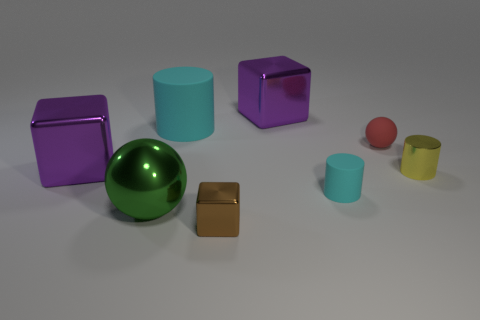There is a thing that is to the right of the large matte object and behind the red matte object; what is its shape?
Provide a short and direct response. Cube. There is a purple shiny thing that is behind the large purple thing that is on the left side of the brown metallic thing; what is its shape?
Give a very brief answer. Cube. Is the shape of the yellow thing the same as the big cyan thing?
Make the answer very short. Yes. What is the material of the small cylinder that is the same color as the large cylinder?
Your answer should be compact. Rubber. Is the large cylinder the same color as the small rubber cylinder?
Offer a very short reply. Yes. What number of purple things are behind the cylinder that is on the right side of the sphere that is right of the small cyan matte object?
Offer a very short reply. 2. There is another tiny thing that is the same material as the small yellow thing; what shape is it?
Make the answer very short. Cube. What is the cyan object that is behind the large object that is on the left side of the sphere in front of the red matte ball made of?
Keep it short and to the point. Rubber. What is the size of the other cyan object that is the same shape as the tiny cyan object?
Your answer should be compact. Large. The big green object has what shape?
Keep it short and to the point. Sphere. 